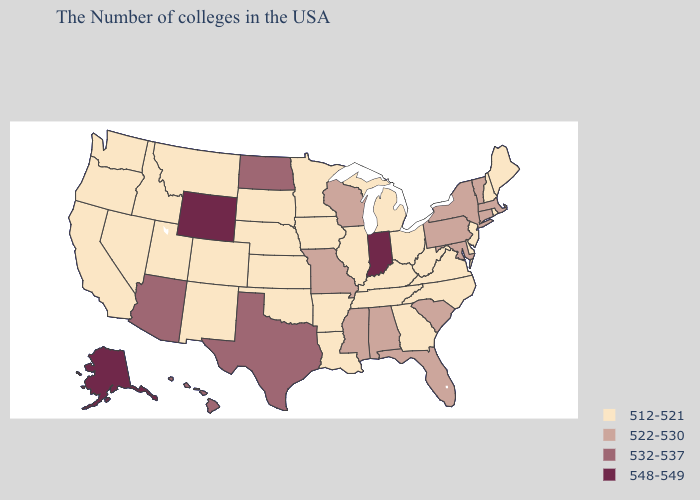What is the value of Pennsylvania?
Concise answer only. 522-530. Does Georgia have the same value as Alabama?
Be succinct. No. Does Alabama have a higher value than Kentucky?
Concise answer only. Yes. What is the value of Idaho?
Short answer required. 512-521. Does Illinois have a lower value than Virginia?
Be succinct. No. Among the states that border South Carolina , which have the highest value?
Quick response, please. North Carolina, Georgia. Name the states that have a value in the range 532-537?
Answer briefly. Texas, North Dakota, Arizona, Hawaii. Is the legend a continuous bar?
Quick response, please. No. What is the lowest value in the USA?
Quick response, please. 512-521. Which states have the lowest value in the USA?
Answer briefly. Maine, Rhode Island, New Hampshire, New Jersey, Delaware, Virginia, North Carolina, West Virginia, Ohio, Georgia, Michigan, Kentucky, Tennessee, Illinois, Louisiana, Arkansas, Minnesota, Iowa, Kansas, Nebraska, Oklahoma, South Dakota, Colorado, New Mexico, Utah, Montana, Idaho, Nevada, California, Washington, Oregon. Is the legend a continuous bar?
Keep it brief. No. Name the states that have a value in the range 512-521?
Concise answer only. Maine, Rhode Island, New Hampshire, New Jersey, Delaware, Virginia, North Carolina, West Virginia, Ohio, Georgia, Michigan, Kentucky, Tennessee, Illinois, Louisiana, Arkansas, Minnesota, Iowa, Kansas, Nebraska, Oklahoma, South Dakota, Colorado, New Mexico, Utah, Montana, Idaho, Nevada, California, Washington, Oregon. Which states have the highest value in the USA?
Quick response, please. Indiana, Wyoming, Alaska. Name the states that have a value in the range 512-521?
Write a very short answer. Maine, Rhode Island, New Hampshire, New Jersey, Delaware, Virginia, North Carolina, West Virginia, Ohio, Georgia, Michigan, Kentucky, Tennessee, Illinois, Louisiana, Arkansas, Minnesota, Iowa, Kansas, Nebraska, Oklahoma, South Dakota, Colorado, New Mexico, Utah, Montana, Idaho, Nevada, California, Washington, Oregon. What is the value of Wyoming?
Quick response, please. 548-549. 